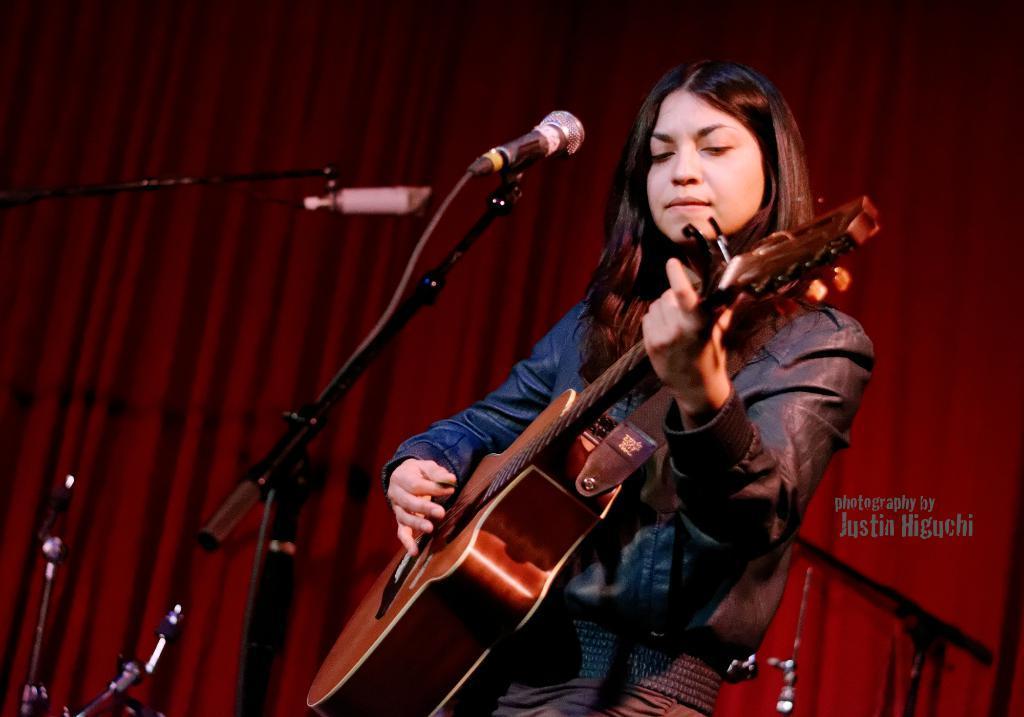How would you summarize this image in a sentence or two? In the image there is a person standing and playing guitar. At the back there is a red curtain and at the left there are microphones. 